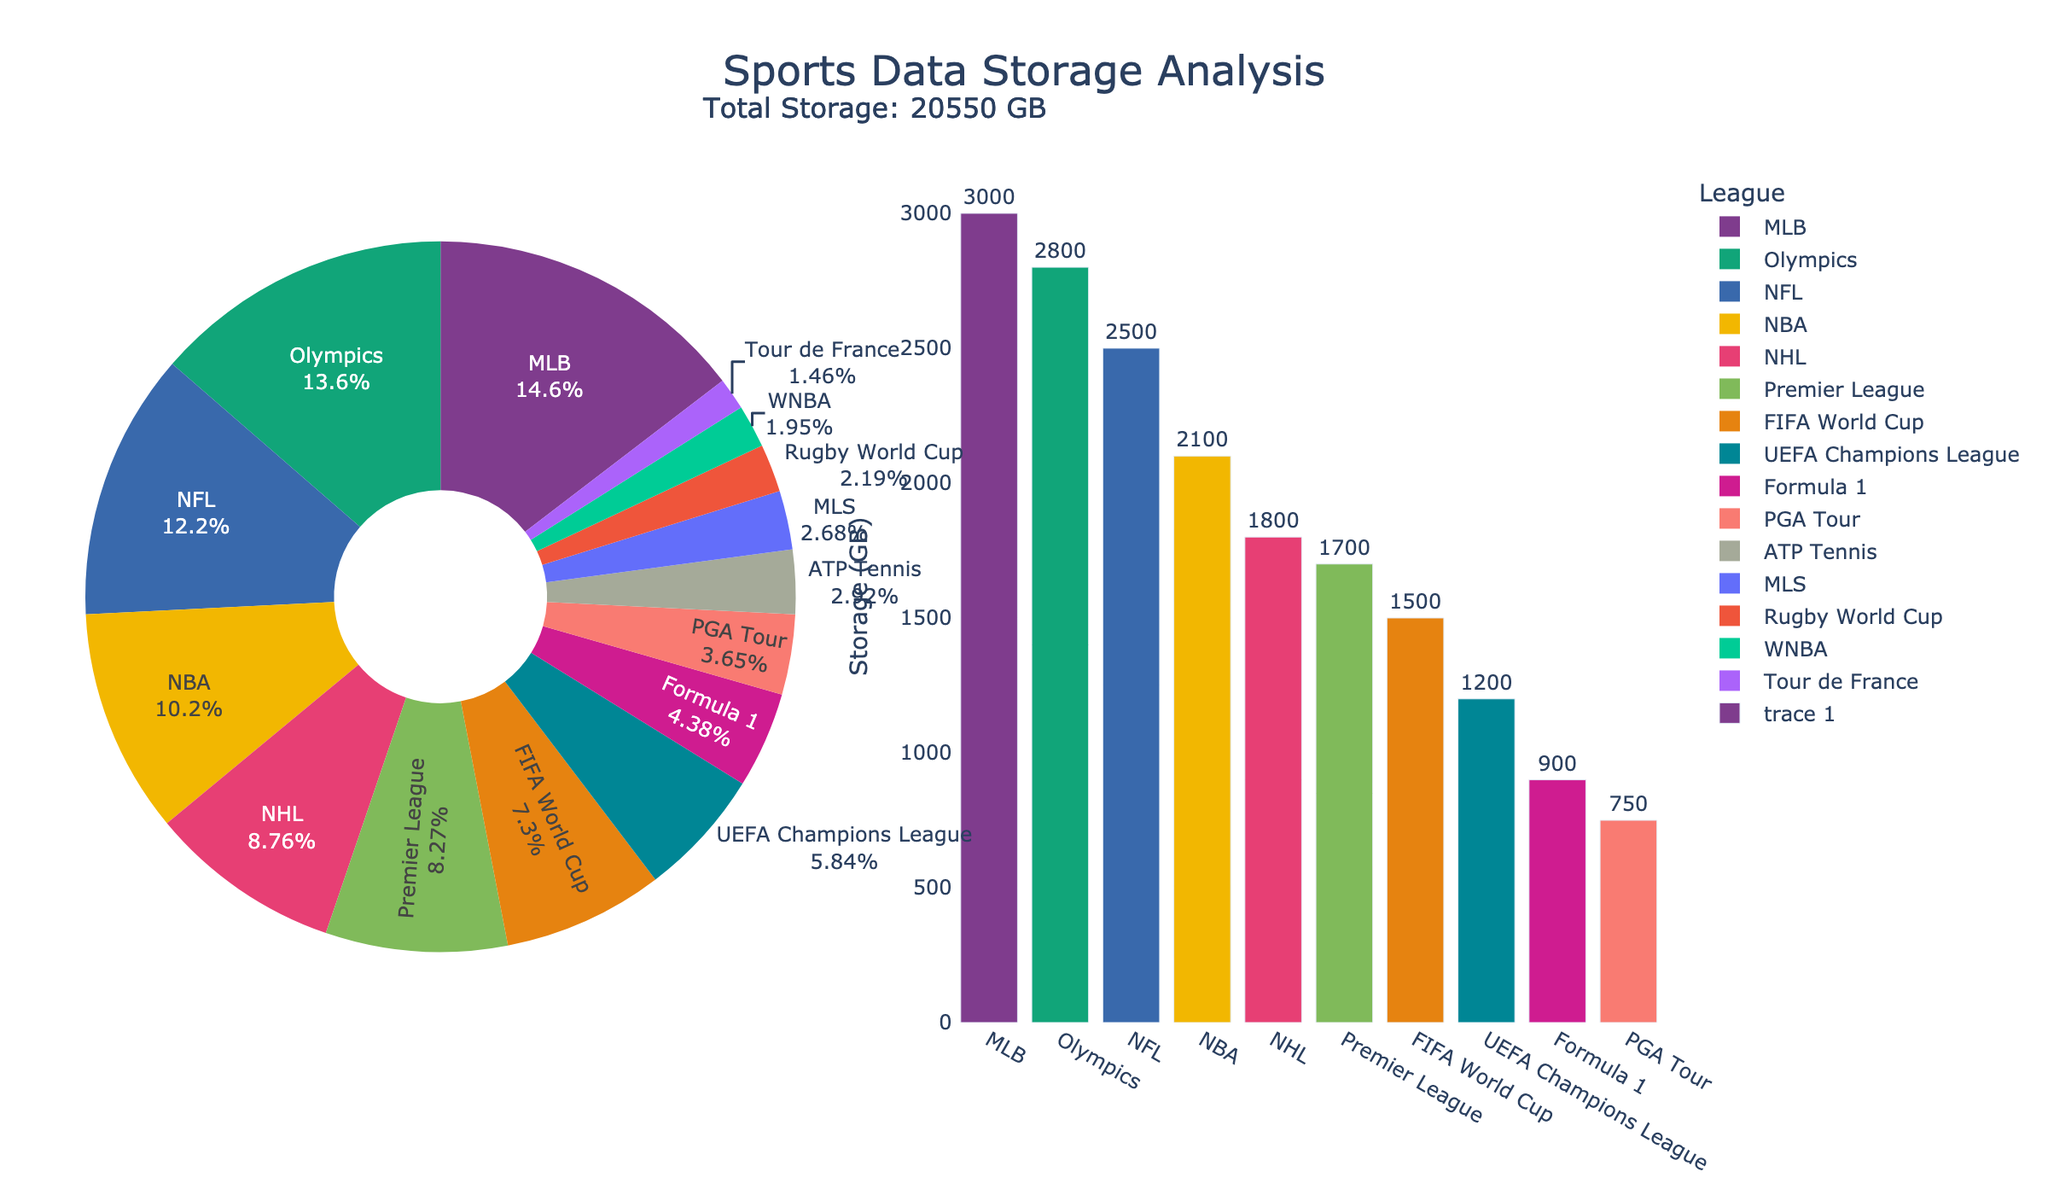What percentage of the total storage is allocated to the NFL? Look at the pie chart segment for the NFL. It shows both the label and the percentage of total storage allocated to the NFL.
Answer: 20% Which league uses more storage, the NBA or the Premier League? Compare the bar heights for the NBA and the Premier League on the bar chart. The NBA bar is higher than the Premier League bar, indicating that the NBA uses more storage.
Answer: NBA What is the total storage allocated to the FIFA World Cup and the UEFA Champions League combined? Find the storage values for both the FIFA World Cup (1500 GB) and the UEFA Champions League (1200 GB) from either the bar chart or pie chart, and sum them up: 1500 + 1200 = 2700 GB.
Answer: 2700 GB Is the storage allocated to the Olympics greater or less than the total storage allocated to the MLB and NHL combined? From the charts, the Olympics use 2800 GB. The MLB uses 3000 GB and the NHL 1800 GB. Summing the MLB and NHL storage: 3000 + 1800 = 4800 GB. 2800 GB is less than 4800 GB.
Answer: Less Rank the top three leagues by storage allocated. By examining the bar chart, the leagues with the highest allocated storage are MLB (3000 GB), Olympics (2800 GB), and NFL (2500 GB) in descending order.
Answer: MLB, Olympics, NFL What is the smallest storage allocation shown on the pie chart? Look at the smallest segment of the pie chart. The label for Tour de France shows it has the smallest storage allocation of 300 GB.
Answer: Tour de France How much more storage does the MLS use compared to the WNBA? The storage for MLS is 550 GB and for WNBA is 400 GB. The difference is calculated as 550 - 400 = 150 GB.
Answer: 150 GB What is the total storage used by leagues with more than 2000 GB of storage? From the charts, the leagues above 2000 GB are NFL (2500 GB), NBA (2100 GB), MLB (3000 GB), and Olympics (2800 GB). Summing their storage: 2500 + 2100 + 3000 + 2800 = 10400 GB.
Answer: 10400 GB What can be inferred about the storage allocation pattern from the bar chart? The bar chart shows that a few leagues consume significantly more storage, with a steep drop after the top few (MLB, Olympics, NFL), indicating a high concentration of storage usage among top leagues.
Answer: Storage is concentrated among top leagues Which league has a storage allocation closest to the average storage across all leagues? First, find the total storage and number of leagues: Total = 23450 GB, Number of leagues = 15. Average storage = 23450 / 15 ≈ 1563.33 GB. The closest league is the FIFA World Cup with 1500 GB.
Answer: FIFA World Cup 